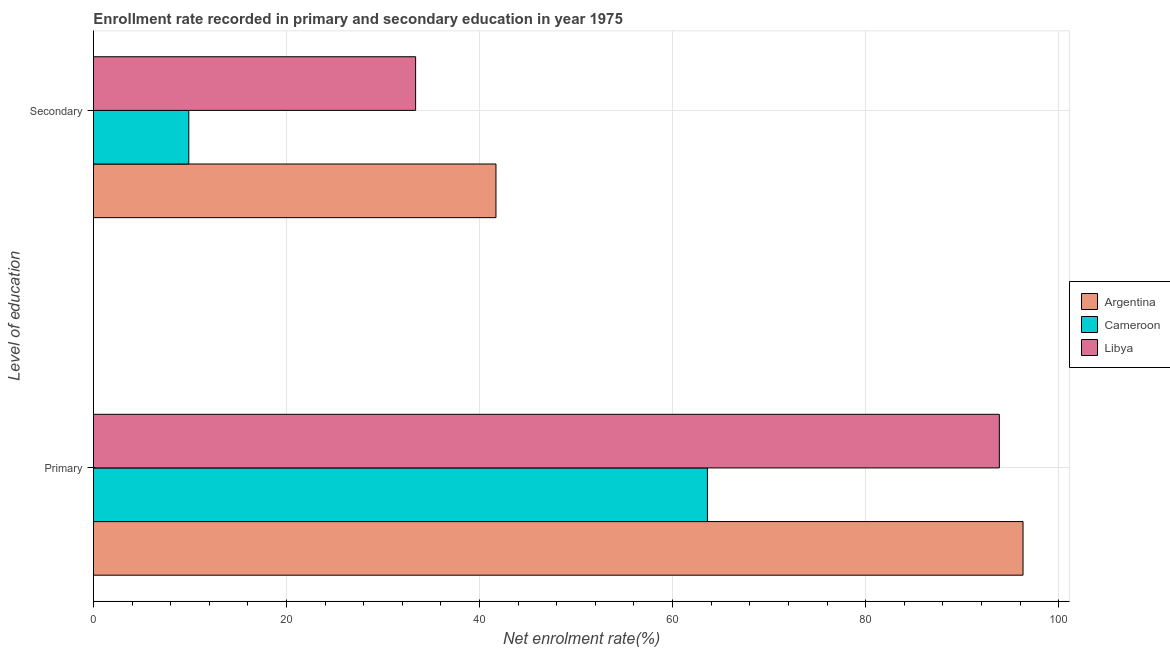How many groups of bars are there?
Provide a short and direct response. 2. How many bars are there on the 2nd tick from the top?
Offer a terse response. 3. What is the label of the 1st group of bars from the top?
Ensure brevity in your answer.  Secondary. What is the enrollment rate in primary education in Libya?
Your answer should be very brief. 93.86. Across all countries, what is the maximum enrollment rate in secondary education?
Give a very brief answer. 41.7. Across all countries, what is the minimum enrollment rate in primary education?
Offer a terse response. 63.61. In which country was the enrollment rate in primary education minimum?
Provide a short and direct response. Cameroon. What is the total enrollment rate in primary education in the graph?
Your answer should be very brief. 253.78. What is the difference between the enrollment rate in secondary education in Cameroon and that in Argentina?
Your response must be concise. -31.83. What is the difference between the enrollment rate in secondary education in Libya and the enrollment rate in primary education in Argentina?
Your response must be concise. -62.93. What is the average enrollment rate in primary education per country?
Give a very brief answer. 84.59. What is the difference between the enrollment rate in primary education and enrollment rate in secondary education in Argentina?
Provide a short and direct response. 54.61. What is the ratio of the enrollment rate in secondary education in Cameroon to that in Argentina?
Your answer should be compact. 0.24. What does the 1st bar from the top in Secondary represents?
Ensure brevity in your answer.  Libya. What does the 2nd bar from the bottom in Primary represents?
Offer a terse response. Cameroon. How many bars are there?
Your answer should be very brief. 6. How many countries are there in the graph?
Keep it short and to the point. 3. What is the difference between two consecutive major ticks on the X-axis?
Offer a very short reply. 20. Does the graph contain any zero values?
Offer a terse response. No. What is the title of the graph?
Your response must be concise. Enrollment rate recorded in primary and secondary education in year 1975. What is the label or title of the X-axis?
Provide a short and direct response. Net enrolment rate(%). What is the label or title of the Y-axis?
Offer a very short reply. Level of education. What is the Net enrolment rate(%) of Argentina in Primary?
Your answer should be compact. 96.31. What is the Net enrolment rate(%) in Cameroon in Primary?
Ensure brevity in your answer.  63.61. What is the Net enrolment rate(%) in Libya in Primary?
Offer a very short reply. 93.86. What is the Net enrolment rate(%) of Argentina in Secondary?
Offer a terse response. 41.7. What is the Net enrolment rate(%) of Cameroon in Secondary?
Keep it short and to the point. 9.88. What is the Net enrolment rate(%) in Libya in Secondary?
Your response must be concise. 33.38. Across all Level of education, what is the maximum Net enrolment rate(%) of Argentina?
Your answer should be very brief. 96.31. Across all Level of education, what is the maximum Net enrolment rate(%) in Cameroon?
Offer a very short reply. 63.61. Across all Level of education, what is the maximum Net enrolment rate(%) in Libya?
Your response must be concise. 93.86. Across all Level of education, what is the minimum Net enrolment rate(%) in Argentina?
Your answer should be very brief. 41.7. Across all Level of education, what is the minimum Net enrolment rate(%) in Cameroon?
Your answer should be very brief. 9.88. Across all Level of education, what is the minimum Net enrolment rate(%) in Libya?
Ensure brevity in your answer.  33.38. What is the total Net enrolment rate(%) of Argentina in the graph?
Provide a short and direct response. 138.01. What is the total Net enrolment rate(%) of Cameroon in the graph?
Provide a succinct answer. 73.49. What is the total Net enrolment rate(%) of Libya in the graph?
Offer a very short reply. 127.23. What is the difference between the Net enrolment rate(%) in Argentina in Primary and that in Secondary?
Keep it short and to the point. 54.61. What is the difference between the Net enrolment rate(%) of Cameroon in Primary and that in Secondary?
Provide a short and direct response. 53.74. What is the difference between the Net enrolment rate(%) of Libya in Primary and that in Secondary?
Your answer should be very brief. 60.48. What is the difference between the Net enrolment rate(%) in Argentina in Primary and the Net enrolment rate(%) in Cameroon in Secondary?
Keep it short and to the point. 86.43. What is the difference between the Net enrolment rate(%) of Argentina in Primary and the Net enrolment rate(%) of Libya in Secondary?
Keep it short and to the point. 62.93. What is the difference between the Net enrolment rate(%) in Cameroon in Primary and the Net enrolment rate(%) in Libya in Secondary?
Offer a very short reply. 30.23. What is the average Net enrolment rate(%) of Argentina per Level of education?
Keep it short and to the point. 69.01. What is the average Net enrolment rate(%) of Cameroon per Level of education?
Your answer should be compact. 36.74. What is the average Net enrolment rate(%) of Libya per Level of education?
Provide a short and direct response. 63.62. What is the difference between the Net enrolment rate(%) in Argentina and Net enrolment rate(%) in Cameroon in Primary?
Make the answer very short. 32.7. What is the difference between the Net enrolment rate(%) of Argentina and Net enrolment rate(%) of Libya in Primary?
Ensure brevity in your answer.  2.45. What is the difference between the Net enrolment rate(%) of Cameroon and Net enrolment rate(%) of Libya in Primary?
Make the answer very short. -30.24. What is the difference between the Net enrolment rate(%) in Argentina and Net enrolment rate(%) in Cameroon in Secondary?
Offer a very short reply. 31.83. What is the difference between the Net enrolment rate(%) in Argentina and Net enrolment rate(%) in Libya in Secondary?
Your response must be concise. 8.32. What is the difference between the Net enrolment rate(%) of Cameroon and Net enrolment rate(%) of Libya in Secondary?
Provide a succinct answer. -23.5. What is the ratio of the Net enrolment rate(%) of Argentina in Primary to that in Secondary?
Offer a terse response. 2.31. What is the ratio of the Net enrolment rate(%) of Cameroon in Primary to that in Secondary?
Give a very brief answer. 6.44. What is the ratio of the Net enrolment rate(%) of Libya in Primary to that in Secondary?
Provide a succinct answer. 2.81. What is the difference between the highest and the second highest Net enrolment rate(%) of Argentina?
Provide a short and direct response. 54.61. What is the difference between the highest and the second highest Net enrolment rate(%) of Cameroon?
Give a very brief answer. 53.74. What is the difference between the highest and the second highest Net enrolment rate(%) in Libya?
Keep it short and to the point. 60.48. What is the difference between the highest and the lowest Net enrolment rate(%) in Argentina?
Provide a short and direct response. 54.61. What is the difference between the highest and the lowest Net enrolment rate(%) in Cameroon?
Offer a terse response. 53.74. What is the difference between the highest and the lowest Net enrolment rate(%) in Libya?
Your answer should be very brief. 60.48. 